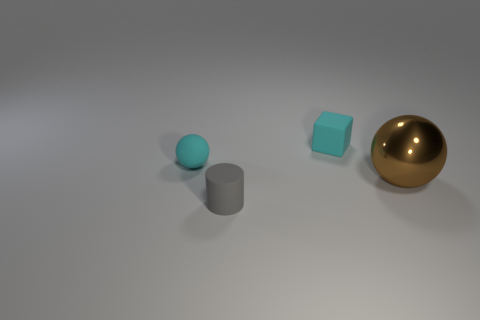How might the sizes of these objects compare to each other? The objects differ in size relative to each other. The small teal sphere is the smallest in volume, followed by the cube, which has slightly more volume due to its shape. The cylinder is taller than both but has a narrow base. The golden sphere, however, is the largest, both in height and volume. If we were to compare them, we might think of the small sphere as roughly the size of a marble, the cube as a standard dice, the cylinder as like a cup, and the gold sphere as similar in size to a grapefruit. 